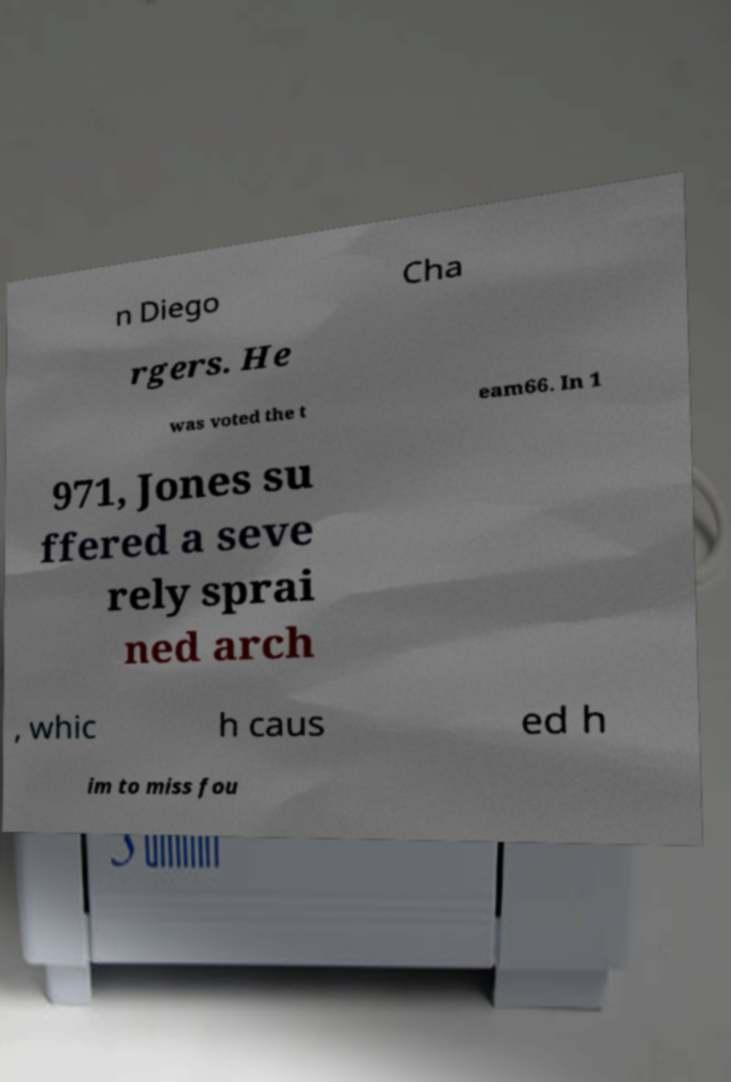Could you extract and type out the text from this image? n Diego Cha rgers. He was voted the t eam66. In 1 971, Jones su ffered a seve rely sprai ned arch , whic h caus ed h im to miss fou 